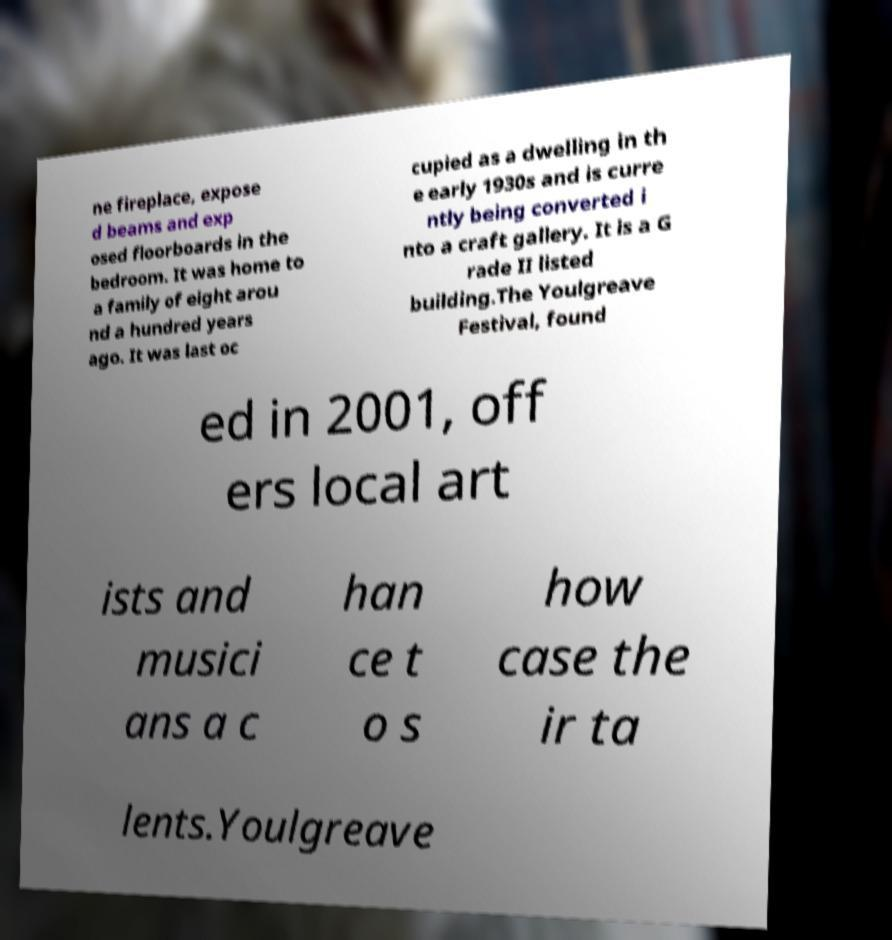Please identify and transcribe the text found in this image. ne fireplace, expose d beams and exp osed floorboards in the bedroom. It was home to a family of eight arou nd a hundred years ago. It was last oc cupied as a dwelling in th e early 1930s and is curre ntly being converted i nto a craft gallery. It is a G rade II listed building.The Youlgreave Festival, found ed in 2001, off ers local art ists and musici ans a c han ce t o s how case the ir ta lents.Youlgreave 